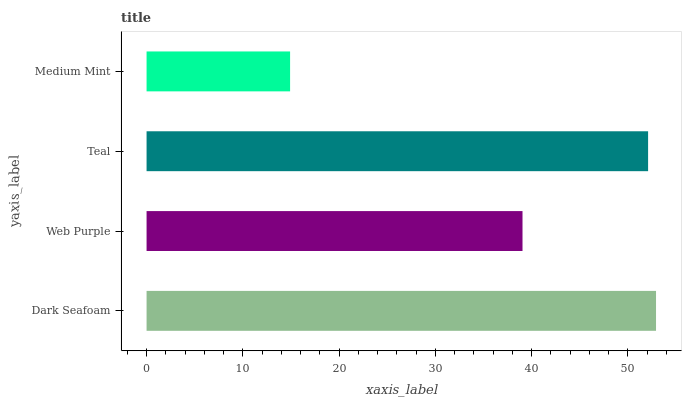Is Medium Mint the minimum?
Answer yes or no. Yes. Is Dark Seafoam the maximum?
Answer yes or no. Yes. Is Web Purple the minimum?
Answer yes or no. No. Is Web Purple the maximum?
Answer yes or no. No. Is Dark Seafoam greater than Web Purple?
Answer yes or no. Yes. Is Web Purple less than Dark Seafoam?
Answer yes or no. Yes. Is Web Purple greater than Dark Seafoam?
Answer yes or no. No. Is Dark Seafoam less than Web Purple?
Answer yes or no. No. Is Teal the high median?
Answer yes or no. Yes. Is Web Purple the low median?
Answer yes or no. Yes. Is Medium Mint the high median?
Answer yes or no. No. Is Medium Mint the low median?
Answer yes or no. No. 